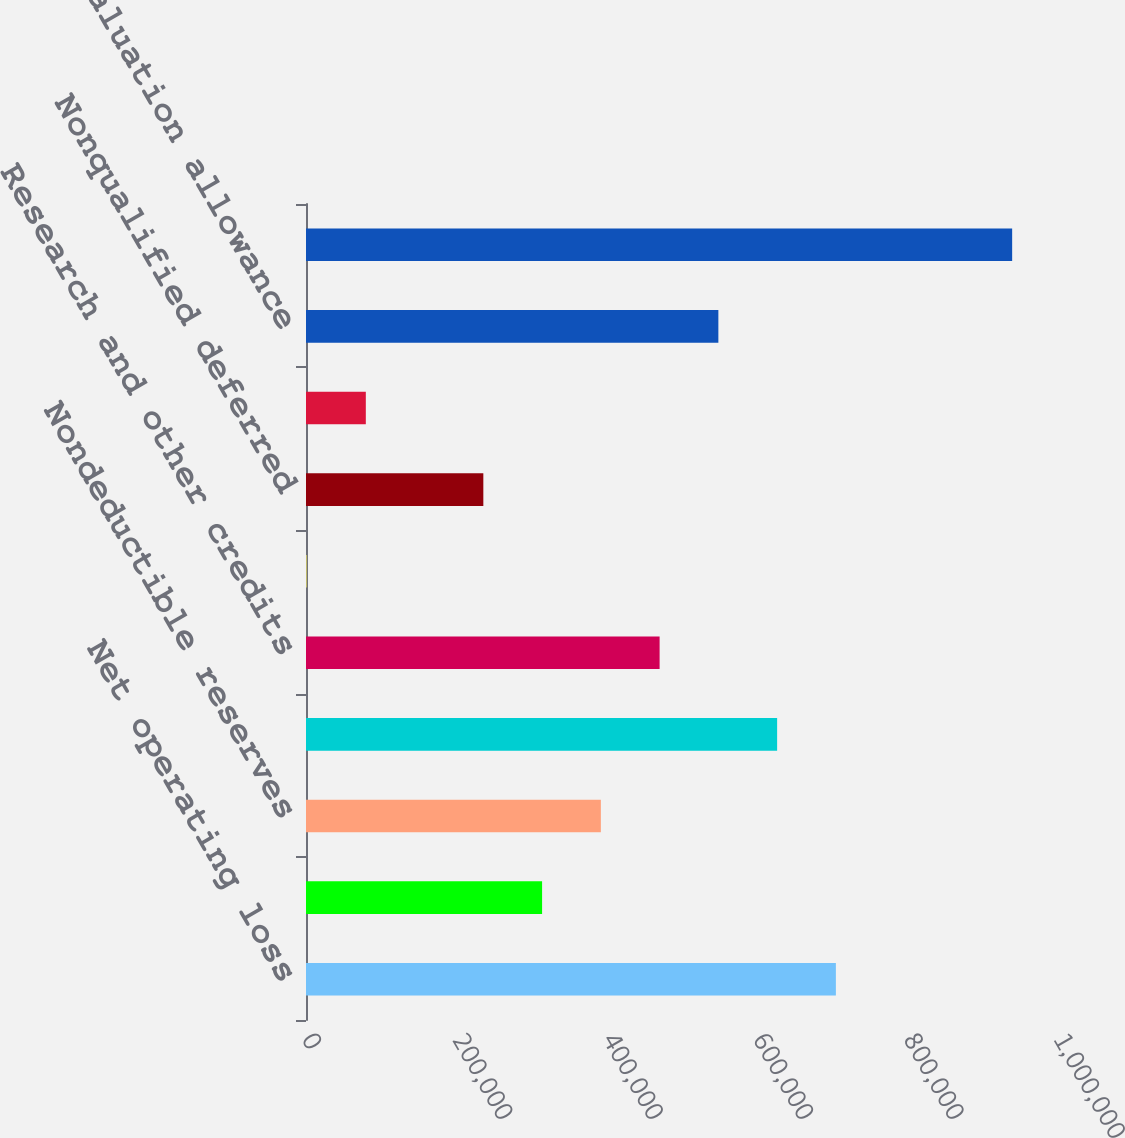<chart> <loc_0><loc_0><loc_500><loc_500><bar_chart><fcel>Net operating loss<fcel>Nondeductible accruals<fcel>Nondeductible reserves<fcel>Stock-based compensation<fcel>Research and other credits<fcel>Convertible notes issuance<fcel>Nonqualified deferred<fcel>Other temporary differences<fcel>Less valuation allowance<fcel>Depreciation and amortization<nl><fcel>704634<fcel>313954<fcel>392090<fcel>626498<fcel>470226<fcel>1410<fcel>235818<fcel>79546<fcel>548362<fcel>939042<nl></chart> 